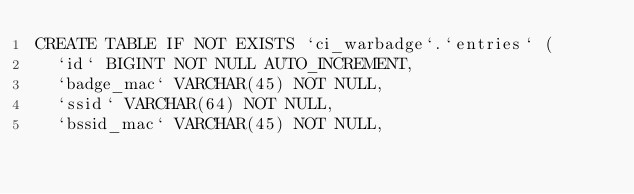Convert code to text. <code><loc_0><loc_0><loc_500><loc_500><_SQL_>CREATE TABLE IF NOT EXISTS `ci_warbadge`.`entries` (
  `id` BIGINT NOT NULL AUTO_INCREMENT,
  `badge_mac` VARCHAR(45) NOT NULL,
  `ssid` VARCHAR(64) NOT NULL,
  `bssid_mac` VARCHAR(45) NOT NULL,</code> 